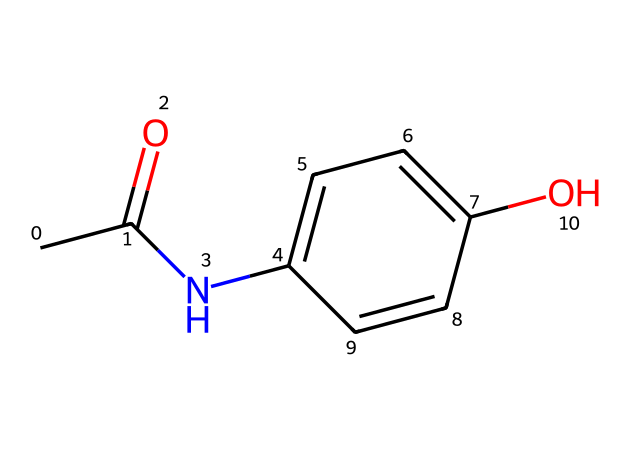What is the name of this chemical? The chemical is commonly identified as acetaminophen, which is a widely used painkiller. You can determine this from its structure and the functional groups present, particularly the amide group and the hydroxyl group.
Answer: acetaminophen How many carbon atoms are present in the structure? By counting the carbon (C) atoms in the SMILES representation, we can see there are eight carbon atoms present in total. Each carbon in the ring and the aliphatic chain contributes to this count.
Answer: 8 What functional groups are present in this chemical? The chemical contains an amide group (N-C=O) and a hydroxyl group (O-H). The presence of these groups can be deduced from their arrangement in the chemical structure.
Answer: amide, hydroxyl What makes benzene rings important in painkillers like this one? Benzene rings are crucial in painkillers due to their ability to stabilize the overall molecule and influence its interaction with biological targets. This stabilization assists in binding to receptors effectively, impacting pain relief.
Answer: stabilization How many rings are present in this chemical structure? Analyzing the chemical, you can observe that there is one ring structure in the molecule, which is the benzene ring that consists of six carbon atoms connected in a cyclic arrangement.
Answer: 1 What is the role of the hydroxyl group in this structure? The hydroxyl group in acetaminophen plays a significant role in enhancing the solubility of the compound in water, which is essential for its pharmacological activity and effectiveness as a painkiller.
Answer: solubility Which part of this chemical primarily contributes to its analgesic properties? The benzene ring system along with the amide functional group works synergistically, with the benzene providing hydrophobic characteristics while the amide enhances interaction at the target sites related to pain pathways.
Answer: benzene ring, amide 